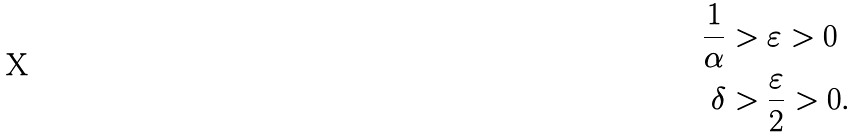Convert formula to latex. <formula><loc_0><loc_0><loc_500><loc_500>\frac { 1 } { \alpha } & > \varepsilon > 0 \\ \delta & > \frac { \varepsilon } { 2 } > 0 .</formula> 